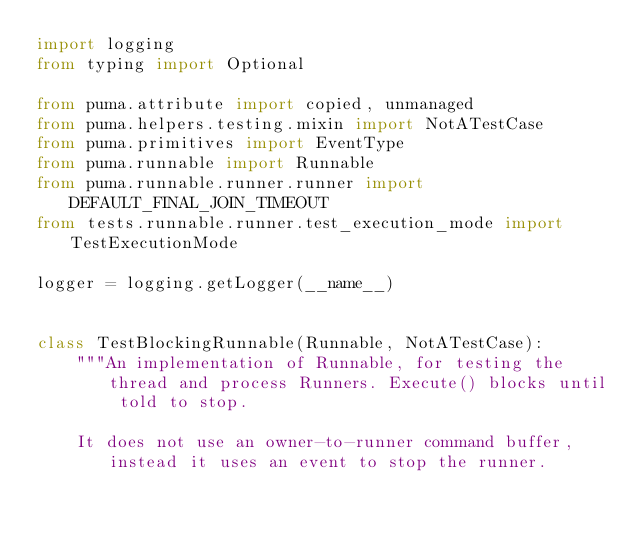<code> <loc_0><loc_0><loc_500><loc_500><_Python_>import logging
from typing import Optional

from puma.attribute import copied, unmanaged
from puma.helpers.testing.mixin import NotATestCase
from puma.primitives import EventType
from puma.runnable import Runnable
from puma.runnable.runner.runner import DEFAULT_FINAL_JOIN_TIMEOUT
from tests.runnable.runner.test_execution_mode import TestExecutionMode

logger = logging.getLogger(__name__)


class TestBlockingRunnable(Runnable, NotATestCase):
    """An implementation of Runnable, for testing the thread and process Runners. Execute() blocks until told to stop.

    It does not use an owner-to-runner command buffer, instead it uses an event to stop the runner.</code> 